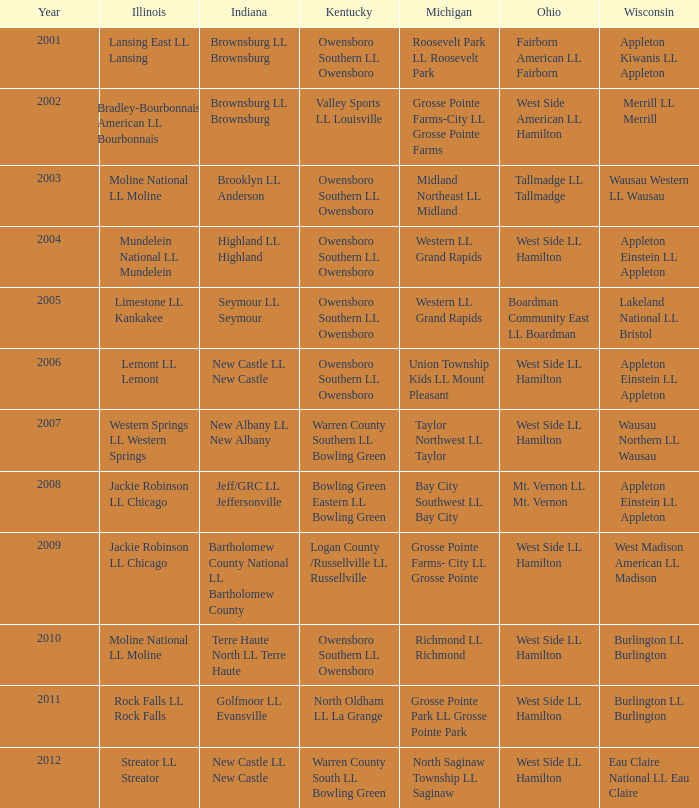When the little league team from kentucky was known as warren county south ll bowling green, which team was from ohio? West Side LL Hamilton. 